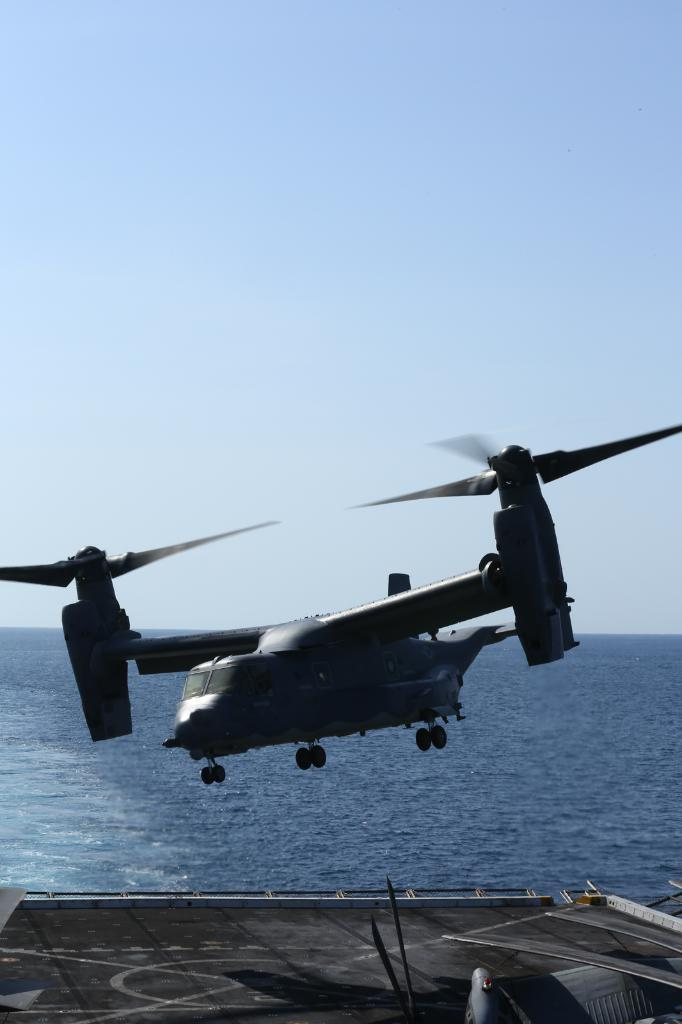What is located on the platform in the image? There is an object on the platform in the image. What can be seen in the air in the image? There is a helicopter in the air in the image. What type of natural feature is visible in the background of the image? There is water visible in the background of the image. What is visible at the top of the image? The sky is visible at the top of the image. How many slaves are visible in the image? There are no slaves present in the image. What type of ticket can be seen in the image? There is no ticket present in the image. 